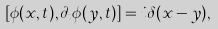<formula> <loc_0><loc_0><loc_500><loc_500>[ \phi ( x , t ) , \partial _ { t } \phi ( y , t ) ] = i \delta ( x - y ) ,</formula> 